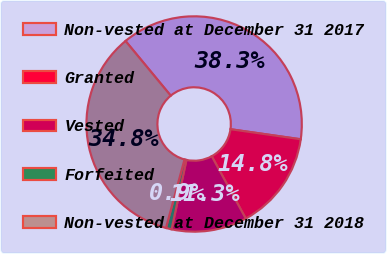Convert chart to OTSL. <chart><loc_0><loc_0><loc_500><loc_500><pie_chart><fcel>Non-vested at December 31 2017<fcel>Granted<fcel>Vested<fcel>Forfeited<fcel>Non-vested at December 31 2018<nl><fcel>38.26%<fcel>14.78%<fcel>11.31%<fcel>0.86%<fcel>34.79%<nl></chart> 